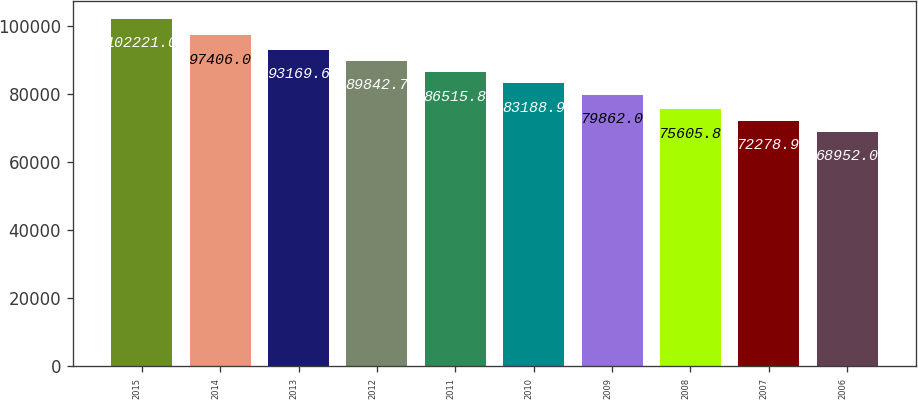Convert chart to OTSL. <chart><loc_0><loc_0><loc_500><loc_500><bar_chart><fcel>2015<fcel>2014<fcel>2013<fcel>2012<fcel>2011<fcel>2010<fcel>2009<fcel>2008<fcel>2007<fcel>2006<nl><fcel>102221<fcel>97406<fcel>93169.6<fcel>89842.7<fcel>86515.8<fcel>83188.9<fcel>79862<fcel>75605.8<fcel>72278.9<fcel>68952<nl></chart> 